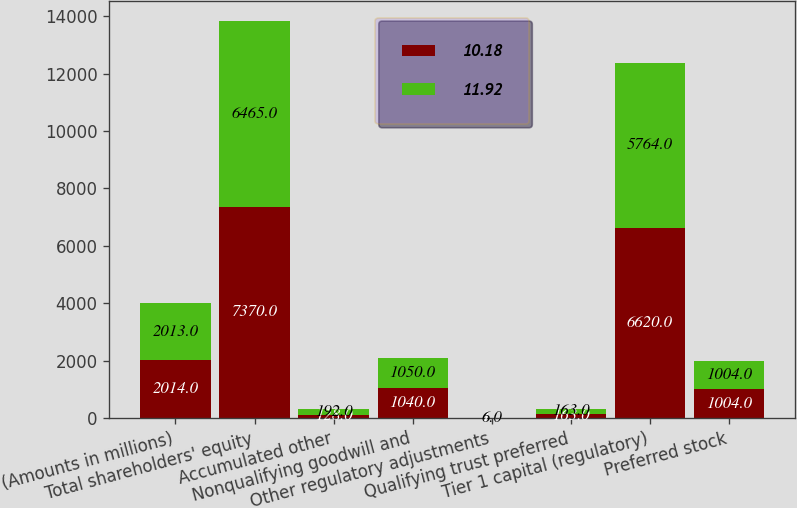Convert chart. <chart><loc_0><loc_0><loc_500><loc_500><stacked_bar_chart><ecel><fcel>(Amounts in millions)<fcel>Total shareholders' equity<fcel>Accumulated other<fcel>Nonqualifying goodwill and<fcel>Other regulatory adjustments<fcel>Qualifying trust preferred<fcel>Tier 1 capital (regulatory)<fcel>Preferred stock<nl><fcel>10.18<fcel>2014<fcel>7370<fcel>128<fcel>1040<fcel>1<fcel>163<fcel>6620<fcel>1004<nl><fcel>11.92<fcel>2013<fcel>6465<fcel>192<fcel>1050<fcel>6<fcel>163<fcel>5764<fcel>1004<nl></chart> 